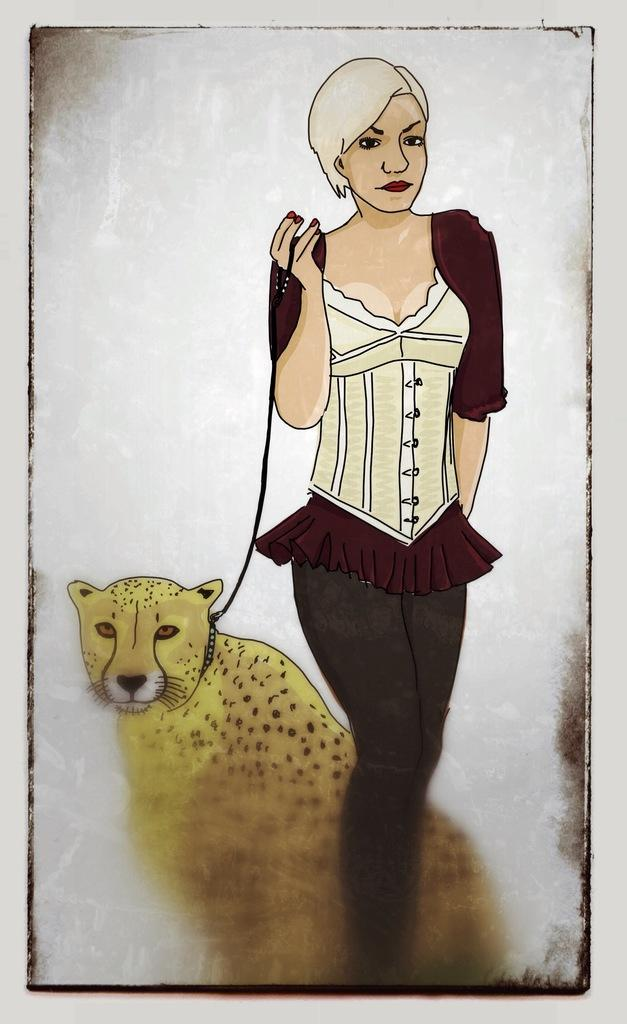What type of image is in the picture? There is an animated image of a woman in the picture. What is the woman doing in the image? The woman is standing in the image. What is the woman holding in the image? The woman is holding a rope in the image. What is the rope tied to in the image? The rope is tied to a leopard in the image. What type of gold jewelry is the woman wearing in the image? There is no gold jewelry visible on the woman in the image. What song is the woman singing in the image? The image is animated and does not contain any audio, so it is impossible to determine if the woman is singing or what song she might be singing. 